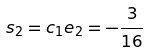<formula> <loc_0><loc_0><loc_500><loc_500>s _ { 2 } = c _ { 1 } e _ { 2 } = - \frac { 3 } { 1 6 }</formula> 